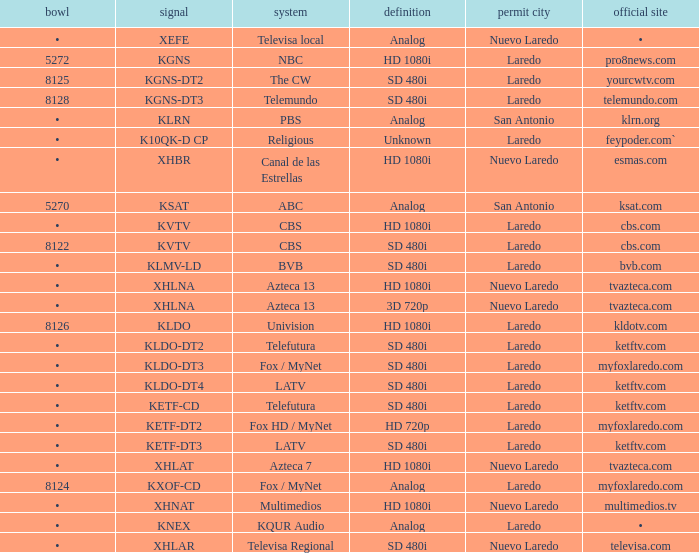Name the city of license with resolution of sd 480i and official website of telemundo.com Laredo. 